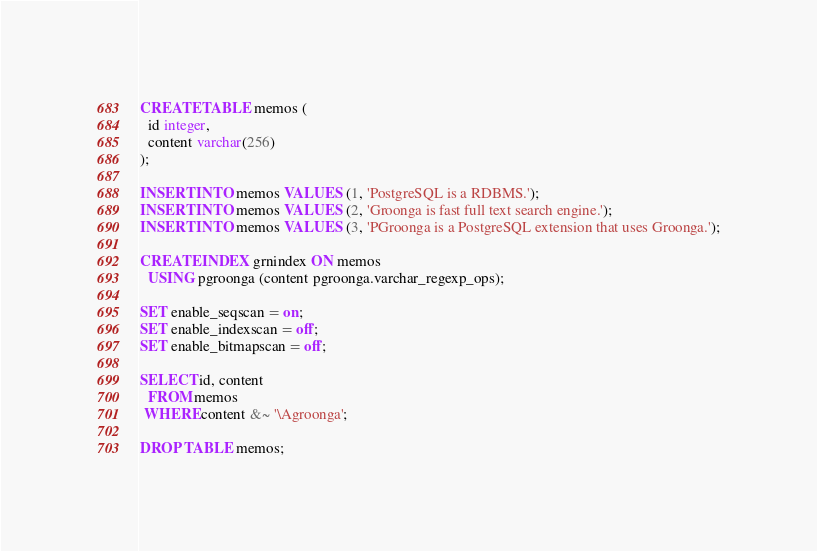<code> <loc_0><loc_0><loc_500><loc_500><_SQL_>CREATE TABLE memos (
  id integer,
  content varchar(256)
);

INSERT INTO memos VALUES (1, 'PostgreSQL is a RDBMS.');
INSERT INTO memos VALUES (2, 'Groonga is fast full text search engine.');
INSERT INTO memos VALUES (3, 'PGroonga is a PostgreSQL extension that uses Groonga.');

CREATE INDEX grnindex ON memos
  USING pgroonga (content pgroonga.varchar_regexp_ops);

SET enable_seqscan = on;
SET enable_indexscan = off;
SET enable_bitmapscan = off;

SELECT id, content
  FROM memos
 WHERE content &~ '\Agroonga';

DROP TABLE memos;
</code> 